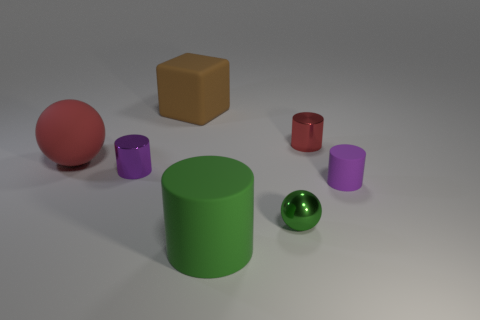Subtract all purple metallic cylinders. How many cylinders are left? 3 Add 1 brown matte things. How many objects exist? 8 Subtract all cylinders. How many objects are left? 3 Subtract all red cylinders. How many cylinders are left? 3 Subtract all cyan blocks. How many purple cylinders are left? 2 Subtract all cyan cylinders. Subtract all yellow blocks. How many cylinders are left? 4 Subtract all rubber cubes. Subtract all purple matte things. How many objects are left? 5 Add 5 small objects. How many small objects are left? 9 Add 6 green objects. How many green objects exist? 8 Subtract 0 purple cubes. How many objects are left? 7 